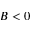<formula> <loc_0><loc_0><loc_500><loc_500>B < 0</formula> 